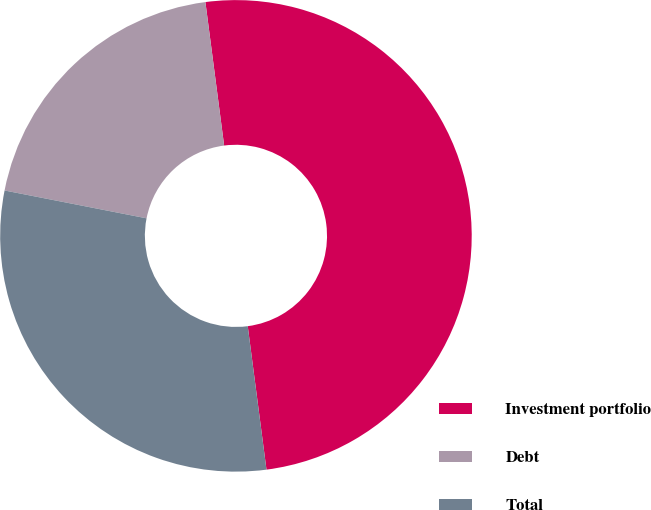Convert chart. <chart><loc_0><loc_0><loc_500><loc_500><pie_chart><fcel>Investment portfolio<fcel>Debt<fcel>Total<nl><fcel>50.0%<fcel>19.85%<fcel>30.15%<nl></chart> 